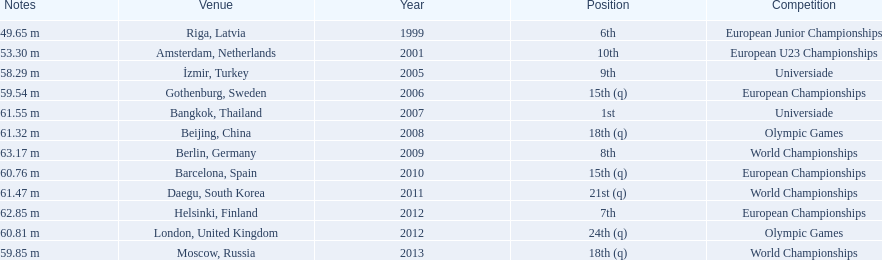What are the total number of times european junior championships is listed as the competition? 1. 